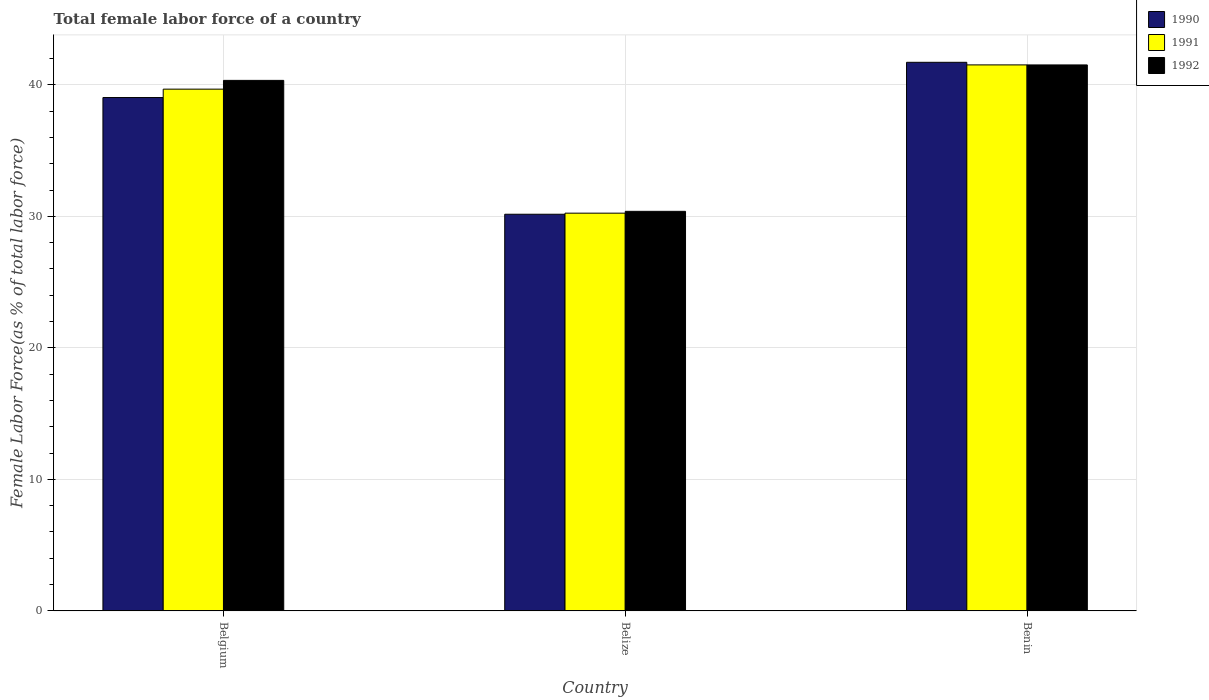How many groups of bars are there?
Your answer should be compact. 3. How many bars are there on the 3rd tick from the right?
Give a very brief answer. 3. What is the label of the 1st group of bars from the left?
Provide a short and direct response. Belgium. In how many cases, is the number of bars for a given country not equal to the number of legend labels?
Give a very brief answer. 0. What is the percentage of female labor force in 1990 in Belize?
Keep it short and to the point. 30.16. Across all countries, what is the maximum percentage of female labor force in 1992?
Keep it short and to the point. 41.52. Across all countries, what is the minimum percentage of female labor force in 1990?
Your answer should be very brief. 30.16. In which country was the percentage of female labor force in 1991 maximum?
Offer a terse response. Benin. In which country was the percentage of female labor force in 1992 minimum?
Give a very brief answer. Belize. What is the total percentage of female labor force in 1991 in the graph?
Give a very brief answer. 111.44. What is the difference between the percentage of female labor force in 1991 in Belgium and that in Belize?
Make the answer very short. 9.43. What is the difference between the percentage of female labor force in 1991 in Belize and the percentage of female labor force in 1992 in Benin?
Your answer should be very brief. -11.27. What is the average percentage of female labor force in 1991 per country?
Ensure brevity in your answer.  37.15. What is the difference between the percentage of female labor force of/in 1992 and percentage of female labor force of/in 1990 in Belgium?
Provide a succinct answer. 1.31. What is the ratio of the percentage of female labor force in 1991 in Belize to that in Benin?
Provide a succinct answer. 0.73. What is the difference between the highest and the second highest percentage of female labor force in 1991?
Give a very brief answer. 11.27. What is the difference between the highest and the lowest percentage of female labor force in 1990?
Offer a terse response. 11.55. In how many countries, is the percentage of female labor force in 1990 greater than the average percentage of female labor force in 1990 taken over all countries?
Your response must be concise. 2. Is the sum of the percentage of female labor force in 1991 in Belgium and Belize greater than the maximum percentage of female labor force in 1992 across all countries?
Give a very brief answer. Yes. What does the 2nd bar from the right in Belize represents?
Offer a very short reply. 1991. Is it the case that in every country, the sum of the percentage of female labor force in 1992 and percentage of female labor force in 1991 is greater than the percentage of female labor force in 1990?
Give a very brief answer. Yes. How many bars are there?
Provide a short and direct response. 9. Are all the bars in the graph horizontal?
Offer a very short reply. No. Does the graph contain any zero values?
Provide a succinct answer. No. Does the graph contain grids?
Provide a short and direct response. Yes. How are the legend labels stacked?
Your answer should be very brief. Vertical. What is the title of the graph?
Your response must be concise. Total female labor force of a country. Does "1977" appear as one of the legend labels in the graph?
Offer a terse response. No. What is the label or title of the X-axis?
Your response must be concise. Country. What is the label or title of the Y-axis?
Give a very brief answer. Female Labor Force(as % of total labor force). What is the Female Labor Force(as % of total labor force) in 1990 in Belgium?
Provide a succinct answer. 39.04. What is the Female Labor Force(as % of total labor force) of 1991 in Belgium?
Provide a succinct answer. 39.68. What is the Female Labor Force(as % of total labor force) in 1992 in Belgium?
Your answer should be compact. 40.34. What is the Female Labor Force(as % of total labor force) of 1990 in Belize?
Offer a very short reply. 30.16. What is the Female Labor Force(as % of total labor force) in 1991 in Belize?
Your response must be concise. 30.24. What is the Female Labor Force(as % of total labor force) of 1992 in Belize?
Offer a very short reply. 30.38. What is the Female Labor Force(as % of total labor force) in 1990 in Benin?
Make the answer very short. 41.72. What is the Female Labor Force(as % of total labor force) of 1991 in Benin?
Your answer should be compact. 41.52. What is the Female Labor Force(as % of total labor force) in 1992 in Benin?
Make the answer very short. 41.52. Across all countries, what is the maximum Female Labor Force(as % of total labor force) of 1990?
Provide a short and direct response. 41.72. Across all countries, what is the maximum Female Labor Force(as % of total labor force) in 1991?
Keep it short and to the point. 41.52. Across all countries, what is the maximum Female Labor Force(as % of total labor force) of 1992?
Keep it short and to the point. 41.52. Across all countries, what is the minimum Female Labor Force(as % of total labor force) in 1990?
Give a very brief answer. 30.16. Across all countries, what is the minimum Female Labor Force(as % of total labor force) in 1991?
Your answer should be very brief. 30.24. Across all countries, what is the minimum Female Labor Force(as % of total labor force) in 1992?
Offer a terse response. 30.38. What is the total Female Labor Force(as % of total labor force) of 1990 in the graph?
Offer a very short reply. 110.91. What is the total Female Labor Force(as % of total labor force) of 1991 in the graph?
Your response must be concise. 111.44. What is the total Female Labor Force(as % of total labor force) of 1992 in the graph?
Offer a terse response. 112.24. What is the difference between the Female Labor Force(as % of total labor force) in 1990 in Belgium and that in Belize?
Provide a succinct answer. 8.87. What is the difference between the Female Labor Force(as % of total labor force) of 1991 in Belgium and that in Belize?
Give a very brief answer. 9.43. What is the difference between the Female Labor Force(as % of total labor force) of 1992 in Belgium and that in Belize?
Offer a terse response. 9.96. What is the difference between the Female Labor Force(as % of total labor force) of 1990 in Belgium and that in Benin?
Provide a short and direct response. -2.68. What is the difference between the Female Labor Force(as % of total labor force) of 1991 in Belgium and that in Benin?
Ensure brevity in your answer.  -1.84. What is the difference between the Female Labor Force(as % of total labor force) of 1992 in Belgium and that in Benin?
Make the answer very short. -1.18. What is the difference between the Female Labor Force(as % of total labor force) of 1990 in Belize and that in Benin?
Offer a very short reply. -11.55. What is the difference between the Female Labor Force(as % of total labor force) of 1991 in Belize and that in Benin?
Give a very brief answer. -11.27. What is the difference between the Female Labor Force(as % of total labor force) of 1992 in Belize and that in Benin?
Offer a terse response. -11.13. What is the difference between the Female Labor Force(as % of total labor force) of 1990 in Belgium and the Female Labor Force(as % of total labor force) of 1991 in Belize?
Make the answer very short. 8.79. What is the difference between the Female Labor Force(as % of total labor force) in 1990 in Belgium and the Female Labor Force(as % of total labor force) in 1992 in Belize?
Your response must be concise. 8.65. What is the difference between the Female Labor Force(as % of total labor force) of 1991 in Belgium and the Female Labor Force(as % of total labor force) of 1992 in Belize?
Give a very brief answer. 9.29. What is the difference between the Female Labor Force(as % of total labor force) of 1990 in Belgium and the Female Labor Force(as % of total labor force) of 1991 in Benin?
Offer a very short reply. -2.48. What is the difference between the Female Labor Force(as % of total labor force) in 1990 in Belgium and the Female Labor Force(as % of total labor force) in 1992 in Benin?
Your answer should be very brief. -2.48. What is the difference between the Female Labor Force(as % of total labor force) in 1991 in Belgium and the Female Labor Force(as % of total labor force) in 1992 in Benin?
Offer a very short reply. -1.84. What is the difference between the Female Labor Force(as % of total labor force) of 1990 in Belize and the Female Labor Force(as % of total labor force) of 1991 in Benin?
Offer a very short reply. -11.36. What is the difference between the Female Labor Force(as % of total labor force) in 1990 in Belize and the Female Labor Force(as % of total labor force) in 1992 in Benin?
Your answer should be compact. -11.35. What is the difference between the Female Labor Force(as % of total labor force) of 1991 in Belize and the Female Labor Force(as % of total labor force) of 1992 in Benin?
Make the answer very short. -11.27. What is the average Female Labor Force(as % of total labor force) of 1990 per country?
Your answer should be very brief. 36.97. What is the average Female Labor Force(as % of total labor force) in 1991 per country?
Offer a terse response. 37.15. What is the average Female Labor Force(as % of total labor force) of 1992 per country?
Provide a short and direct response. 37.41. What is the difference between the Female Labor Force(as % of total labor force) in 1990 and Female Labor Force(as % of total labor force) in 1991 in Belgium?
Provide a short and direct response. -0.64. What is the difference between the Female Labor Force(as % of total labor force) of 1990 and Female Labor Force(as % of total labor force) of 1992 in Belgium?
Offer a terse response. -1.3. What is the difference between the Female Labor Force(as % of total labor force) in 1991 and Female Labor Force(as % of total labor force) in 1992 in Belgium?
Make the answer very short. -0.67. What is the difference between the Female Labor Force(as % of total labor force) of 1990 and Female Labor Force(as % of total labor force) of 1991 in Belize?
Your answer should be compact. -0.08. What is the difference between the Female Labor Force(as % of total labor force) of 1990 and Female Labor Force(as % of total labor force) of 1992 in Belize?
Offer a very short reply. -0.22. What is the difference between the Female Labor Force(as % of total labor force) in 1991 and Female Labor Force(as % of total labor force) in 1992 in Belize?
Give a very brief answer. -0.14. What is the difference between the Female Labor Force(as % of total labor force) of 1990 and Female Labor Force(as % of total labor force) of 1991 in Benin?
Give a very brief answer. 0.2. What is the difference between the Female Labor Force(as % of total labor force) of 1990 and Female Labor Force(as % of total labor force) of 1992 in Benin?
Provide a short and direct response. 0.2. What is the difference between the Female Labor Force(as % of total labor force) in 1991 and Female Labor Force(as % of total labor force) in 1992 in Benin?
Ensure brevity in your answer.  0. What is the ratio of the Female Labor Force(as % of total labor force) in 1990 in Belgium to that in Belize?
Provide a short and direct response. 1.29. What is the ratio of the Female Labor Force(as % of total labor force) of 1991 in Belgium to that in Belize?
Your answer should be very brief. 1.31. What is the ratio of the Female Labor Force(as % of total labor force) of 1992 in Belgium to that in Belize?
Provide a succinct answer. 1.33. What is the ratio of the Female Labor Force(as % of total labor force) in 1990 in Belgium to that in Benin?
Ensure brevity in your answer.  0.94. What is the ratio of the Female Labor Force(as % of total labor force) of 1991 in Belgium to that in Benin?
Your answer should be compact. 0.96. What is the ratio of the Female Labor Force(as % of total labor force) of 1992 in Belgium to that in Benin?
Provide a succinct answer. 0.97. What is the ratio of the Female Labor Force(as % of total labor force) of 1990 in Belize to that in Benin?
Your answer should be compact. 0.72. What is the ratio of the Female Labor Force(as % of total labor force) in 1991 in Belize to that in Benin?
Your response must be concise. 0.73. What is the ratio of the Female Labor Force(as % of total labor force) of 1992 in Belize to that in Benin?
Keep it short and to the point. 0.73. What is the difference between the highest and the second highest Female Labor Force(as % of total labor force) of 1990?
Give a very brief answer. 2.68. What is the difference between the highest and the second highest Female Labor Force(as % of total labor force) in 1991?
Your answer should be compact. 1.84. What is the difference between the highest and the second highest Female Labor Force(as % of total labor force) of 1992?
Provide a short and direct response. 1.18. What is the difference between the highest and the lowest Female Labor Force(as % of total labor force) in 1990?
Provide a succinct answer. 11.55. What is the difference between the highest and the lowest Female Labor Force(as % of total labor force) in 1991?
Offer a very short reply. 11.27. What is the difference between the highest and the lowest Female Labor Force(as % of total labor force) in 1992?
Offer a very short reply. 11.13. 